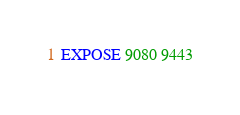Convert code to text. <code><loc_0><loc_0><loc_500><loc_500><_Dockerfile_>
EXPOSE 9080 9443
</code> 